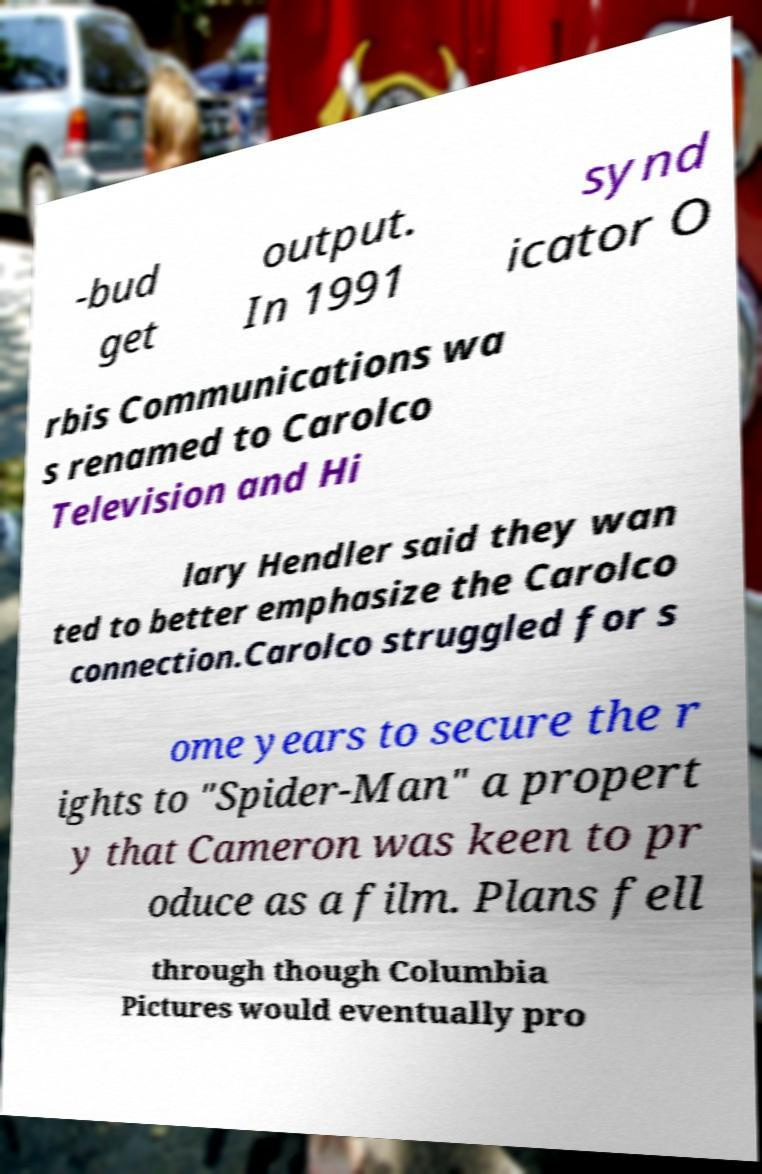Can you read and provide the text displayed in the image?This photo seems to have some interesting text. Can you extract and type it out for me? -bud get output. In 1991 synd icator O rbis Communications wa s renamed to Carolco Television and Hi lary Hendler said they wan ted to better emphasize the Carolco connection.Carolco struggled for s ome years to secure the r ights to "Spider-Man" a propert y that Cameron was keen to pr oduce as a film. Plans fell through though Columbia Pictures would eventually pro 